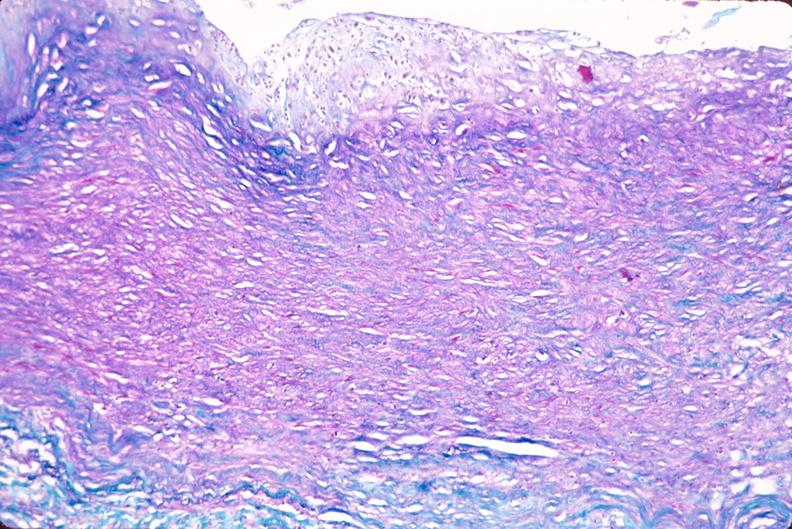s vasculature present?
Answer the question using a single word or phrase. Yes 